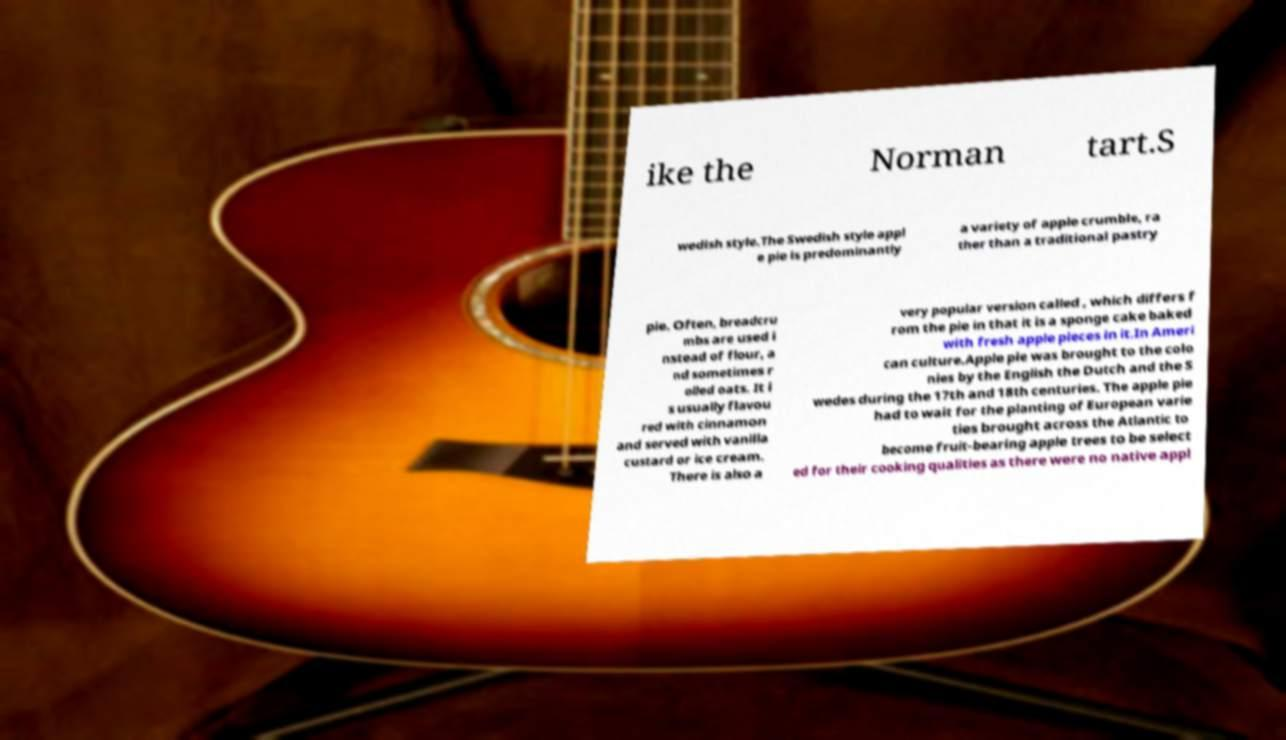Please read and relay the text visible in this image. What does it say? ike the Norman tart.S wedish style.The Swedish style appl e pie is predominantly a variety of apple crumble, ra ther than a traditional pastry pie. Often, breadcru mbs are used i nstead of flour, a nd sometimes r olled oats. It i s usually flavou red with cinnamon and served with vanilla custard or ice cream. There is also a very popular version called , which differs f rom the pie in that it is a sponge cake baked with fresh apple pieces in it.In Ameri can culture.Apple pie was brought to the colo nies by the English the Dutch and the S wedes during the 17th and 18th centuries. The apple pie had to wait for the planting of European varie ties brought across the Atlantic to become fruit-bearing apple trees to be select ed for their cooking qualities as there were no native appl 